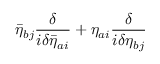<formula> <loc_0><loc_0><loc_500><loc_500>\bar { \eta } _ { b j } \frac { \delta } { i \delta \bar { \eta } _ { a i } } + \eta _ { a i } \frac { \delta } { i \delta \eta _ { b j } }</formula> 